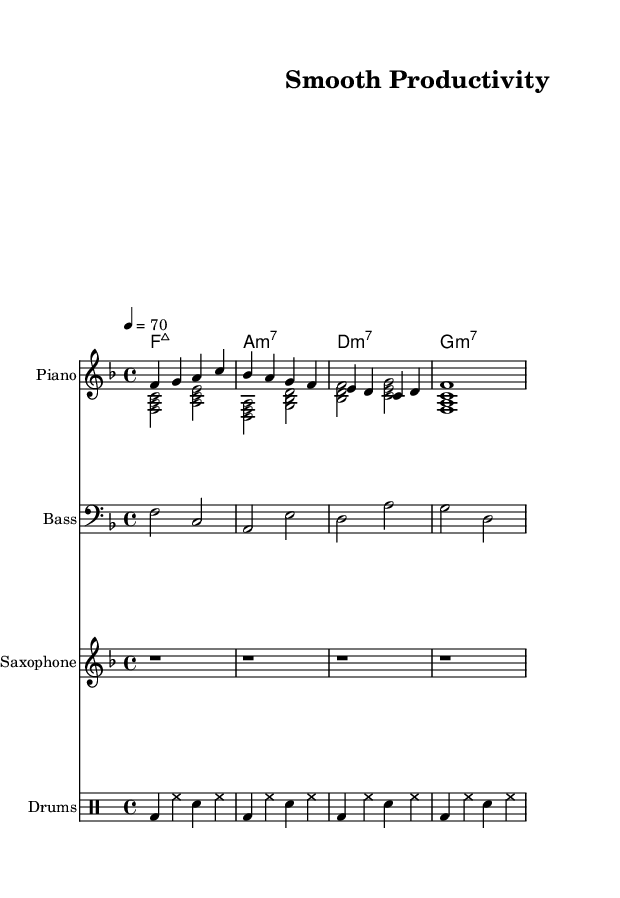What is the key signature of this music? The key signature shown is F major, which has one flat (B flat). This can be determined by looking at the key signature at the beginning of the staff.
Answer: F major What is the time signature of this music? The time signature is 4/4, seen as the fraction at the beginning of the score, which indicates four beats per measure and the quarter note gets one beat.
Answer: 4/4 What is the tempo marking in this music? The tempo marking indicates a speed of quarter note equals seventy beats per minute, which is displayed in the tempo line at the beginning of the music.
Answer: 70 How many measures are present in the sheet music? There are four measures present, identifiable by counting the vertical bar lines that separate the measures.
Answer: 4 What is the first chord indicated in this piece? The first chord shown is F major seven, which is displayed in the chord names section at the beginning of the score and labeled as "f:maj7".
Answer: F major seven Which instrument is indicated as playing the saxophone? The instrument labeled in the staff specifically for that part is called "Saxophone", which is stated in the header of the staff for that voice.
Answer: Saxophone Is there a drum part included in this music sheet? Yes, there is a drum part included, as indicated by the presence of a separate DrumStaff and the drumming notation found within that section.
Answer: Yes 